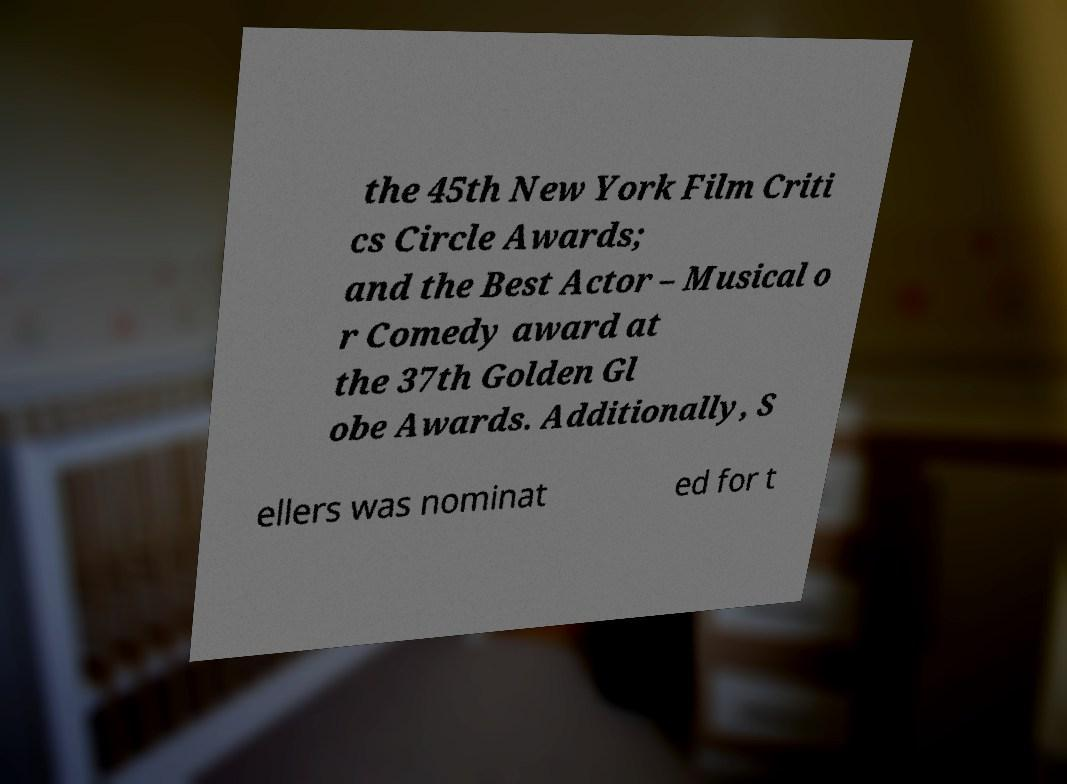Can you read and provide the text displayed in the image?This photo seems to have some interesting text. Can you extract and type it out for me? the 45th New York Film Criti cs Circle Awards; and the Best Actor – Musical o r Comedy award at the 37th Golden Gl obe Awards. Additionally, S ellers was nominat ed for t 